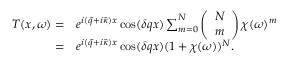<formula> <loc_0><loc_0><loc_500><loc_500>\begin{array} { r l } { T ( x , \omega ) = } & e ^ { i ( \bar { q } + i \bar { \kappa } ) x } \cos ( \delta q x ) \sum _ { m = 0 } ^ { N } \left ( \begin{array} { l } { N } \\ { m } \end{array} \right ) \chi ( \omega ) ^ { m } } \\ { = } & e ^ { i ( \bar { q } + i \bar { \kappa } ) x } \cos ( \delta q x ) ( 1 + \chi ( \omega ) ) ^ { N } . } \end{array}</formula> 